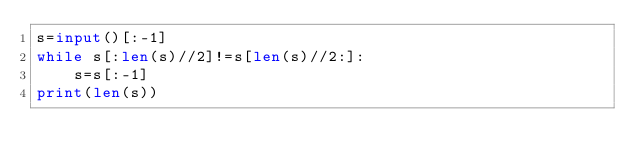<code> <loc_0><loc_0><loc_500><loc_500><_Python_>s=input()[:-1]
while s[:len(s)//2]!=s[len(s)//2:]:
    s=s[:-1]
print(len(s))</code> 